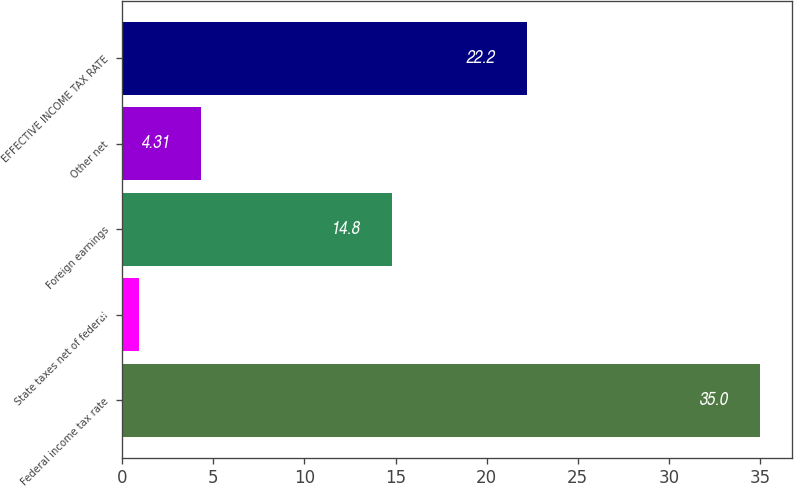Convert chart. <chart><loc_0><loc_0><loc_500><loc_500><bar_chart><fcel>Federal income tax rate<fcel>State taxes net of federal<fcel>Foreign earnings<fcel>Other net<fcel>EFFECTIVE INCOME TAX RATE<nl><fcel>35<fcel>0.9<fcel>14.8<fcel>4.31<fcel>22.2<nl></chart> 